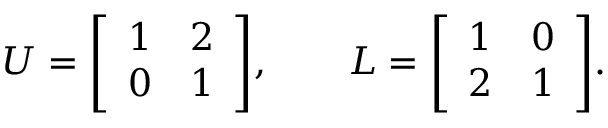Convert formula to latex. <formula><loc_0><loc_0><loc_500><loc_500>U = { \left [ \begin{array} { l l } { 1 } & { 2 } \\ { 0 } & { 1 } \end{array} \right ] } , \quad L = { \left [ \begin{array} { l l } { 1 } & { 0 } \\ { 2 } & { 1 } \end{array} \right ] } .</formula> 